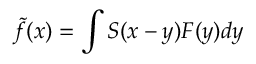<formula> <loc_0><loc_0><loc_500><loc_500>\tilde { f } ( x ) = \int S ( x - y ) F ( y ) d y</formula> 